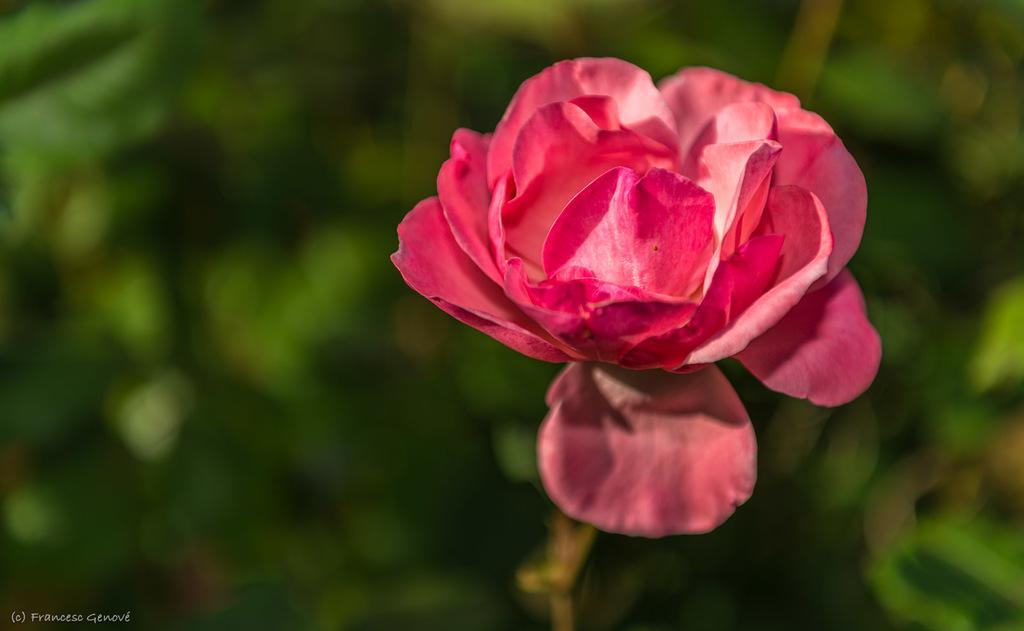What can be found on the bottom left side of the image? There is text on the bottom left side of the image. What type of flower is present in the image? There is a red flower with a stem in the image. What is visible in the background of the image? There are plants in the background of the image. How would you describe the background of the image? The background of the image is blurred. How much money is being exchanged between the feet in the image? There is no money or feet present in the image. What type of wool is being used to create the flower in the image? The image does not depict any wool, as it features a red flower with a stem. 